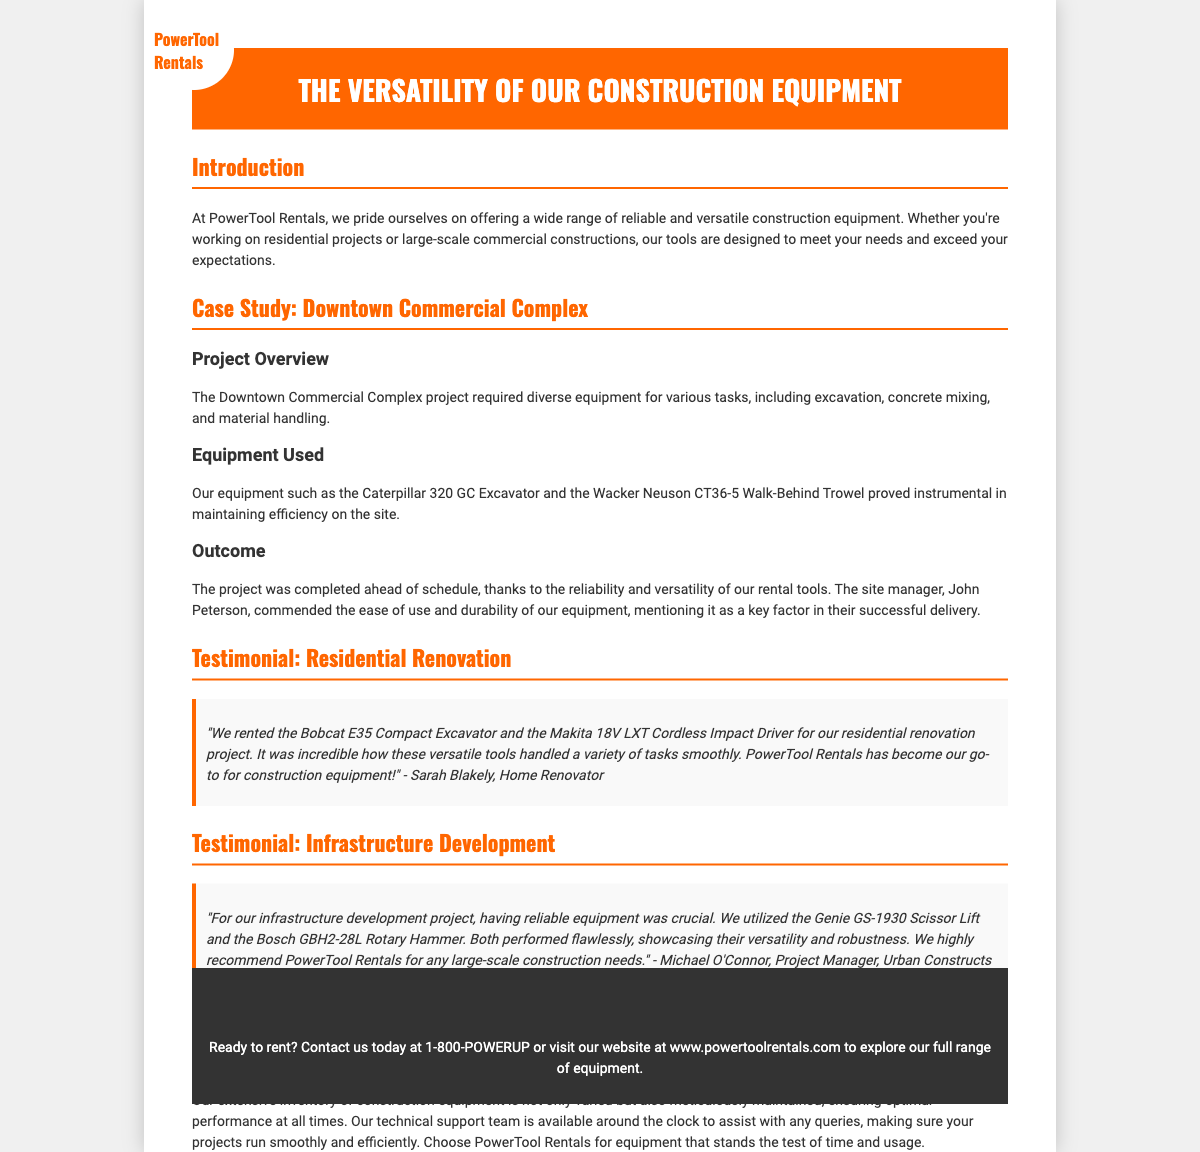What is the title of the document? The title of the document is displayed prominently at the top of the playbill.
Answer: The Versatility of Our Construction Equipment Who is the site manager mentioned in the case study? The site manager's name is given in the outcome section of the case study.
Answer: John Peterson What equipment was used for the Downtown Commercial Complex project? The equipment used is listed in the equipment section under the Downtown Commercial Complex case study.
Answer: Caterpillar 320 GC Excavator and Wacker Neuson CT36-5 Walk-Behind Trowel Who provided a testimonial for the residential renovation project? The testimonial section indicates who provided feedback and their role.
Answer: Sarah Blakely What is the contact phone number for PowerTool Rentals? The contact phone number is stated in the contact section at the bottom of the playbill.
Answer: 1-800-POWERUP What feature of the tools was highlighted in Sarah Blakely's testimonial? Sarah Blakely's testimonial mentions a specific quality of the tools used in her project.
Answer: Versatility What type of project did Michael O'Connor manage? The project type is specified in the testimonial provided by Michael O'Connor.
Answer: Infrastructure development Why should customers choose PowerTool Rentals? The document provides reasons within the 'Why Choose PowerTool Rentals?' section.
Answer: Excellent inventory and support How does the document describe the maintenance of the equipment? The text describes how the equipment is maintained in a certain manner to ensure quality.
Answer: Meticulously maintained 